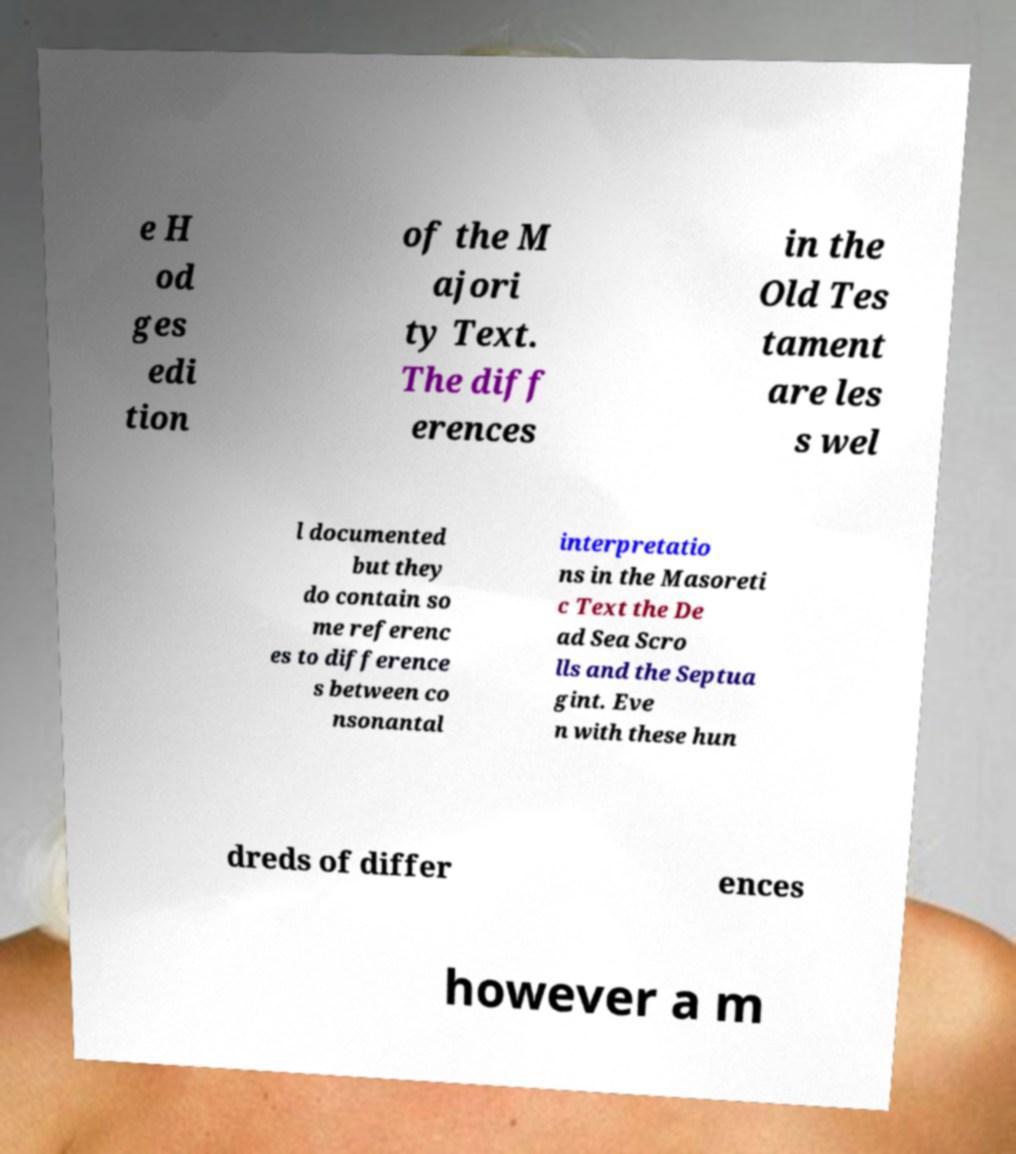Can you accurately transcribe the text from the provided image for me? e H od ges edi tion of the M ajori ty Text. The diff erences in the Old Tes tament are les s wel l documented but they do contain so me referenc es to difference s between co nsonantal interpretatio ns in the Masoreti c Text the De ad Sea Scro lls and the Septua gint. Eve n with these hun dreds of differ ences however a m 